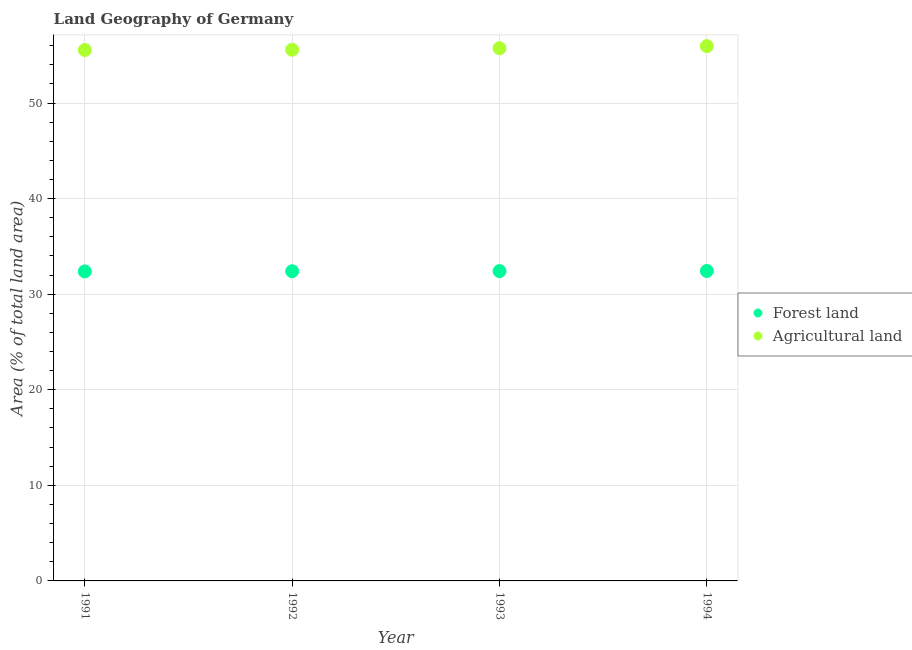What is the percentage of land area under agriculture in 1991?
Offer a very short reply. 55.55. Across all years, what is the maximum percentage of land area under forests?
Provide a short and direct response. 32.43. Across all years, what is the minimum percentage of land area under agriculture?
Ensure brevity in your answer.  55.55. In which year was the percentage of land area under forests minimum?
Your response must be concise. 1991. What is the total percentage of land area under forests in the graph?
Make the answer very short. 129.62. What is the difference between the percentage of land area under agriculture in 1991 and that in 1994?
Keep it short and to the point. -0.4. What is the difference between the percentage of land area under agriculture in 1994 and the percentage of land area under forests in 1993?
Offer a terse response. 23.54. What is the average percentage of land area under agriculture per year?
Keep it short and to the point. 55.7. In the year 1994, what is the difference between the percentage of land area under agriculture and percentage of land area under forests?
Offer a very short reply. 23.52. In how many years, is the percentage of land area under agriculture greater than 6 %?
Offer a very short reply. 4. What is the ratio of the percentage of land area under forests in 1992 to that in 1993?
Your response must be concise. 1. Is the percentage of land area under forests in 1992 less than that in 1994?
Keep it short and to the point. Yes. What is the difference between the highest and the second highest percentage of land area under forests?
Your response must be concise. 0.02. What is the difference between the highest and the lowest percentage of land area under forests?
Offer a terse response. 0.05. In how many years, is the percentage of land area under forests greater than the average percentage of land area under forests taken over all years?
Your answer should be compact. 2. Is the sum of the percentage of land area under forests in 1991 and 1994 greater than the maximum percentage of land area under agriculture across all years?
Your answer should be very brief. Yes. Is the percentage of land area under agriculture strictly less than the percentage of land area under forests over the years?
Give a very brief answer. No. How many years are there in the graph?
Provide a succinct answer. 4. What is the difference between two consecutive major ticks on the Y-axis?
Your response must be concise. 10. Does the graph contain any zero values?
Keep it short and to the point. No. Does the graph contain grids?
Your response must be concise. Yes. How many legend labels are there?
Your response must be concise. 2. How are the legend labels stacked?
Offer a terse response. Vertical. What is the title of the graph?
Give a very brief answer. Land Geography of Germany. Does "Stunting" appear as one of the legend labels in the graph?
Provide a succinct answer. No. What is the label or title of the X-axis?
Your answer should be very brief. Year. What is the label or title of the Y-axis?
Your answer should be very brief. Area (% of total land area). What is the Area (% of total land area) of Forest land in 1991?
Give a very brief answer. 32.38. What is the Area (% of total land area) in Agricultural land in 1991?
Give a very brief answer. 55.55. What is the Area (% of total land area) of Forest land in 1992?
Make the answer very short. 32.4. What is the Area (% of total land area) of Agricultural land in 1992?
Keep it short and to the point. 55.57. What is the Area (% of total land area) of Forest land in 1993?
Offer a terse response. 32.41. What is the Area (% of total land area) in Agricultural land in 1993?
Your response must be concise. 55.73. What is the Area (% of total land area) in Forest land in 1994?
Give a very brief answer. 32.43. What is the Area (% of total land area) in Agricultural land in 1994?
Provide a succinct answer. 55.95. Across all years, what is the maximum Area (% of total land area) of Forest land?
Your answer should be very brief. 32.43. Across all years, what is the maximum Area (% of total land area) in Agricultural land?
Your answer should be compact. 55.95. Across all years, what is the minimum Area (% of total land area) in Forest land?
Ensure brevity in your answer.  32.38. Across all years, what is the minimum Area (% of total land area) of Agricultural land?
Your response must be concise. 55.55. What is the total Area (% of total land area) in Forest land in the graph?
Give a very brief answer. 129.62. What is the total Area (% of total land area) of Agricultural land in the graph?
Offer a terse response. 222.8. What is the difference between the Area (% of total land area) of Forest land in 1991 and that in 1992?
Give a very brief answer. -0.02. What is the difference between the Area (% of total land area) in Agricultural land in 1991 and that in 1992?
Provide a short and direct response. -0.03. What is the difference between the Area (% of total land area) of Forest land in 1991 and that in 1993?
Make the answer very short. -0.03. What is the difference between the Area (% of total land area) in Agricultural land in 1991 and that in 1993?
Give a very brief answer. -0.19. What is the difference between the Area (% of total land area) of Forest land in 1991 and that in 1994?
Give a very brief answer. -0.05. What is the difference between the Area (% of total land area) in Agricultural land in 1991 and that in 1994?
Your answer should be compact. -0.4. What is the difference between the Area (% of total land area) of Forest land in 1992 and that in 1993?
Ensure brevity in your answer.  -0.02. What is the difference between the Area (% of total land area) in Agricultural land in 1992 and that in 1993?
Your response must be concise. -0.16. What is the difference between the Area (% of total land area) of Forest land in 1992 and that in 1994?
Keep it short and to the point. -0.03. What is the difference between the Area (% of total land area) of Agricultural land in 1992 and that in 1994?
Your answer should be very brief. -0.38. What is the difference between the Area (% of total land area) of Forest land in 1993 and that in 1994?
Keep it short and to the point. -0.02. What is the difference between the Area (% of total land area) of Agricultural land in 1993 and that in 1994?
Offer a terse response. -0.22. What is the difference between the Area (% of total land area) in Forest land in 1991 and the Area (% of total land area) in Agricultural land in 1992?
Offer a very short reply. -23.19. What is the difference between the Area (% of total land area) of Forest land in 1991 and the Area (% of total land area) of Agricultural land in 1993?
Ensure brevity in your answer.  -23.35. What is the difference between the Area (% of total land area) in Forest land in 1991 and the Area (% of total land area) in Agricultural land in 1994?
Ensure brevity in your answer.  -23.57. What is the difference between the Area (% of total land area) of Forest land in 1992 and the Area (% of total land area) of Agricultural land in 1993?
Your answer should be compact. -23.34. What is the difference between the Area (% of total land area) in Forest land in 1992 and the Area (% of total land area) in Agricultural land in 1994?
Your answer should be compact. -23.55. What is the difference between the Area (% of total land area) in Forest land in 1993 and the Area (% of total land area) in Agricultural land in 1994?
Give a very brief answer. -23.54. What is the average Area (% of total land area) in Forest land per year?
Your answer should be very brief. 32.41. What is the average Area (% of total land area) of Agricultural land per year?
Give a very brief answer. 55.7. In the year 1991, what is the difference between the Area (% of total land area) in Forest land and Area (% of total land area) in Agricultural land?
Offer a very short reply. -23.16. In the year 1992, what is the difference between the Area (% of total land area) of Forest land and Area (% of total land area) of Agricultural land?
Offer a terse response. -23.18. In the year 1993, what is the difference between the Area (% of total land area) in Forest land and Area (% of total land area) in Agricultural land?
Make the answer very short. -23.32. In the year 1994, what is the difference between the Area (% of total land area) in Forest land and Area (% of total land area) in Agricultural land?
Your answer should be compact. -23.52. What is the ratio of the Area (% of total land area) of Forest land in 1991 to that in 1992?
Your response must be concise. 1. What is the ratio of the Area (% of total land area) in Forest land in 1991 to that in 1993?
Ensure brevity in your answer.  1. What is the ratio of the Area (% of total land area) in Agricultural land in 1991 to that in 1993?
Provide a succinct answer. 1. What is the ratio of the Area (% of total land area) in Agricultural land in 1992 to that in 1993?
Give a very brief answer. 1. What is the ratio of the Area (% of total land area) of Forest land in 1992 to that in 1994?
Provide a succinct answer. 1. What is the difference between the highest and the second highest Area (% of total land area) in Forest land?
Provide a succinct answer. 0.02. What is the difference between the highest and the second highest Area (% of total land area) in Agricultural land?
Offer a terse response. 0.22. What is the difference between the highest and the lowest Area (% of total land area) of Forest land?
Your answer should be compact. 0.05. What is the difference between the highest and the lowest Area (% of total land area) in Agricultural land?
Ensure brevity in your answer.  0.4. 